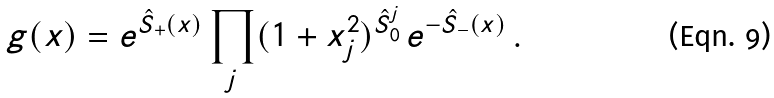<formula> <loc_0><loc_0><loc_500><loc_500>g ( x ) = e ^ { \hat { S } _ { + } ( x ) } \prod _ { j } ( 1 + x _ { j } ^ { 2 } ) ^ { \hat { S } ^ { j } _ { 0 } } \, e ^ { - \hat { S } _ { - } ( x ) } \, .</formula> 